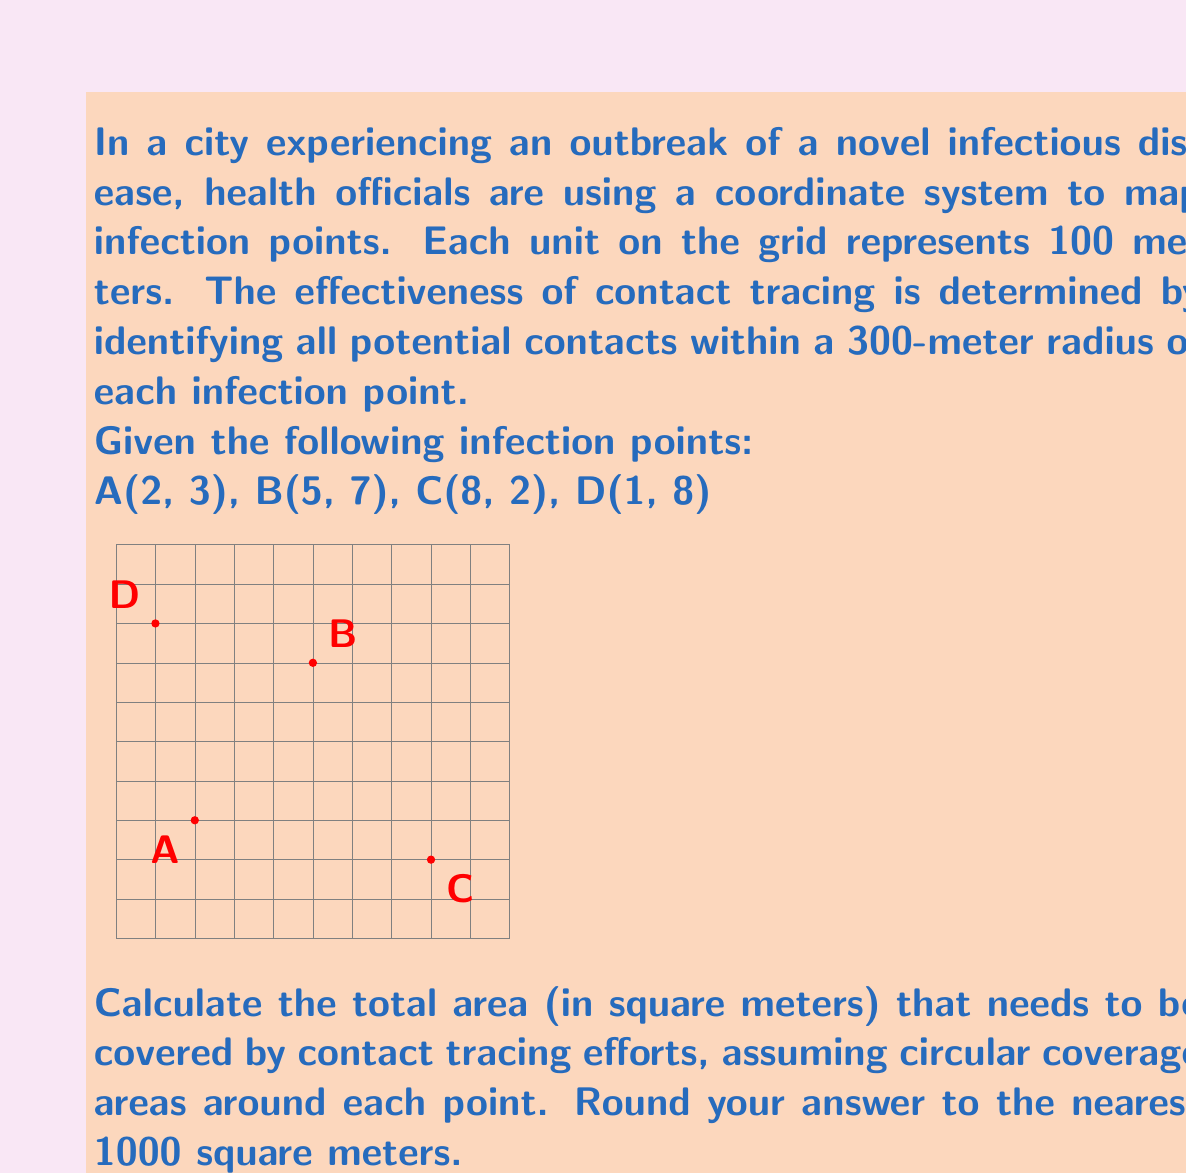Solve this math problem. Let's approach this step-by-step:

1) The radius of each circular coverage area is 300 meters, which is 3 units on our grid.

2) The area of a circle is given by the formula $A = \pi r^2$. For each infection point, the area covered is:

   $A = \pi (3)^2 = 9\pi$ square units

3) Each square unit represents 100m × 100m = 10,000 square meters. So, the area of each circle in square meters is:

   $9\pi \times 10,000 = 90,000\pi$ square meters

4) If the circles didn't overlap, we would simply multiply this by 4 (for the 4 infection points). However, we need to check for overlaps.

5) To check for overlaps, we calculate the distances between each pair of points using the distance formula:

   $d = \sqrt{(x_2-x_1)^2 + (y_2-y_1)^2}$

   AB: $d = \sqrt{(5-2)^2 + (7-3)^2} = \sqrt{34} \approx 5.83$ units
   AC: $d = \sqrt{(8-2)^2 + (2-3)^2} = \sqrt{37} \approx 6.08$ units
   AD: $d = \sqrt{(1-2)^2 + (8-3)^2} = \sqrt{26} \approx 5.10$ units
   BC: $d = \sqrt{(8-5)^2 + (2-7)^2} = \sqrt{34} \approx 5.83$ units
   BD: $d = \sqrt{(1-5)^2 + (8-7)^2} = \sqrt{17} \approx 4.12$ units
   CD: $d = \sqrt{(1-8)^2 + (8-2)^2} = \sqrt{85} \approx 9.22$ units

6) The only pair of points within 6 units (600 meters) of each other is B and D. Their circles will overlap slightly.

7) The exact calculation of the overlap area is complex. As an approximation, we can assume the overlap is about 10% of one circle's area.

8) Therefore, the total area covered is approximately:

   $(4 \times 90,000\pi) - (0.1 \times 90,000\pi) = 3.9 \times 90,000\pi$ square meters

9) Calculate and round to the nearest 1000:

   $3.9 \times 90,000\pi \approx 1,100,000$ square meters
Answer: 1,100,000 square meters 